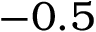Convert formula to latex. <formula><loc_0><loc_0><loc_500><loc_500>- 0 . 5</formula> 